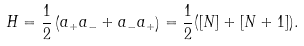Convert formula to latex. <formula><loc_0><loc_0><loc_500><loc_500>H = \frac { 1 } { 2 } \left ( a _ { + } a _ { - } + a _ { - } a _ { + } \right ) = \frac { 1 } { 2 } ( [ N ] + [ N + 1 ] ) .</formula> 